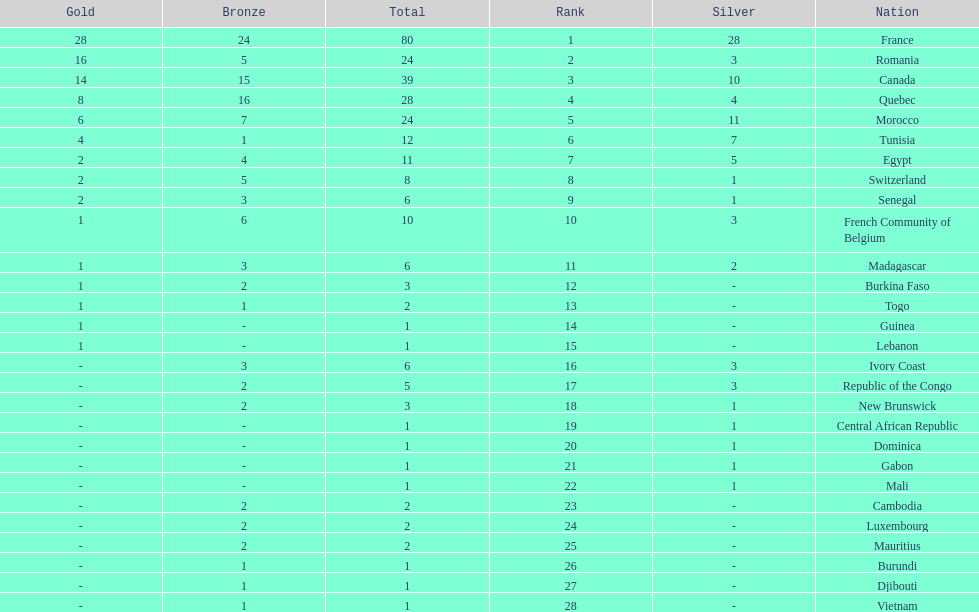What is the difference between france's and egypt's silver medals? 23. 